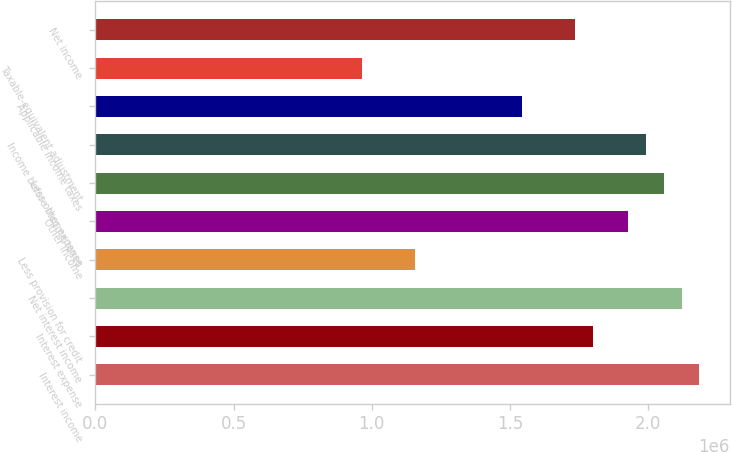Convert chart. <chart><loc_0><loc_0><loc_500><loc_500><bar_chart><fcel>Interest income<fcel>Interest expense<fcel>Net interest income<fcel>Less provision for credit<fcel>Other income<fcel>Less other expense<fcel>Income before income taxes<fcel>Applicable income taxes<fcel>Taxable-equivalent adjustment<fcel>Net income<nl><fcel>2.1843e+06<fcel>1.79883e+06<fcel>2.12005e+06<fcel>1.15639e+06<fcel>1.92732e+06<fcel>2.05581e+06<fcel>1.99157e+06<fcel>1.54186e+06<fcel>963661<fcel>1.73459e+06<nl></chart> 